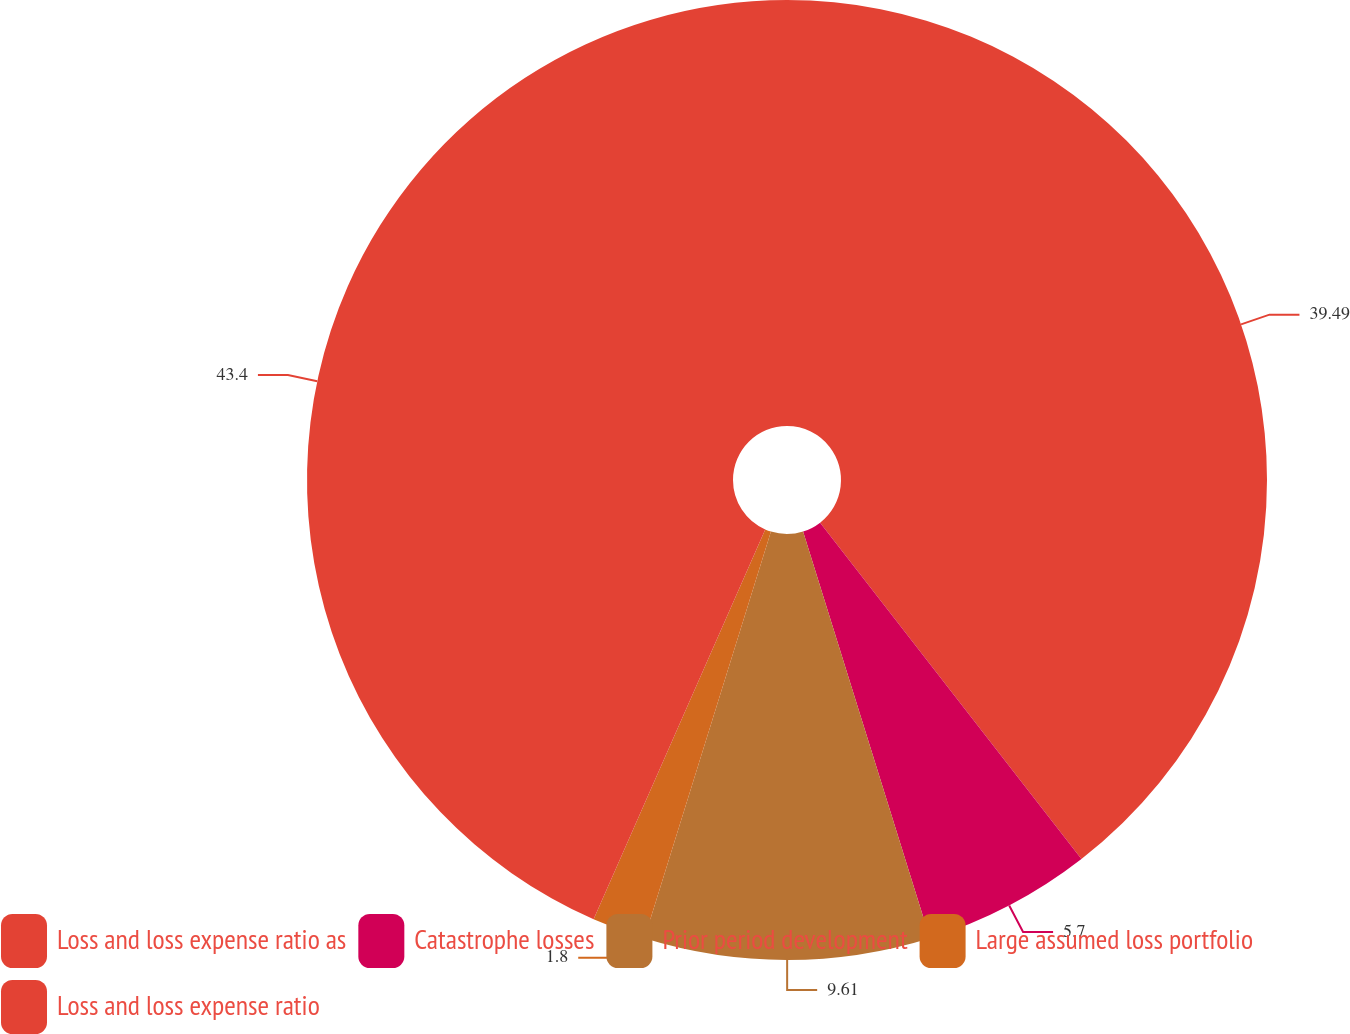Convert chart to OTSL. <chart><loc_0><loc_0><loc_500><loc_500><pie_chart><fcel>Loss and loss expense ratio as<fcel>Catastrophe losses<fcel>Prior period development<fcel>Large assumed loss portfolio<fcel>Loss and loss expense ratio<nl><fcel>39.49%<fcel>5.7%<fcel>9.61%<fcel>1.8%<fcel>43.4%<nl></chart> 